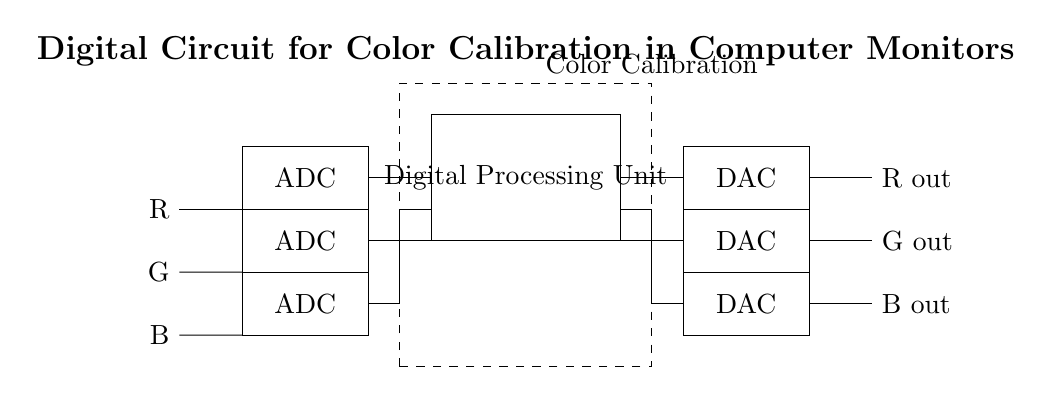What are the outputs of the circuit? The circuit produces outputs labeled as R out, G out, and B out, which represent the red, green, and blue color components, respectively.
Answer: R out, G out, B out How many ADC blocks are present in the circuit? The diagram shows three ADC blocks, each corresponding to one RGB input (Red, Green, Blue).
Answer: Three What is the purpose of the Digital Processing Unit? The Digital Processing Unit processes the signals received from the ADC blocks, preparing them for the DAC blocks to output the calibrated colors.
Answer: Processing What type of circuit is this? The circuit is a digital circuit specifically designed for color calibration in computer monitors.
Answer: Digital Where does the color calibration block fit in the circuit? The color calibration block is positioned between the ADC blocks and the Digital Processing Unit, serving as a component for adjusting the color signals before processing.
Answer: Between ADC and DPU What is the role of the DAC blocks? The DAC blocks convert the processed digital signals from the Digital Processing Unit back into analog signals for output to the monitor.
Answer: Conversion What does the dashed rectangle represent in the circuit? The dashed rectangle signifies the Color Calibration block, indicating its function in the circuit layout visually.
Answer: Color Calibration block 